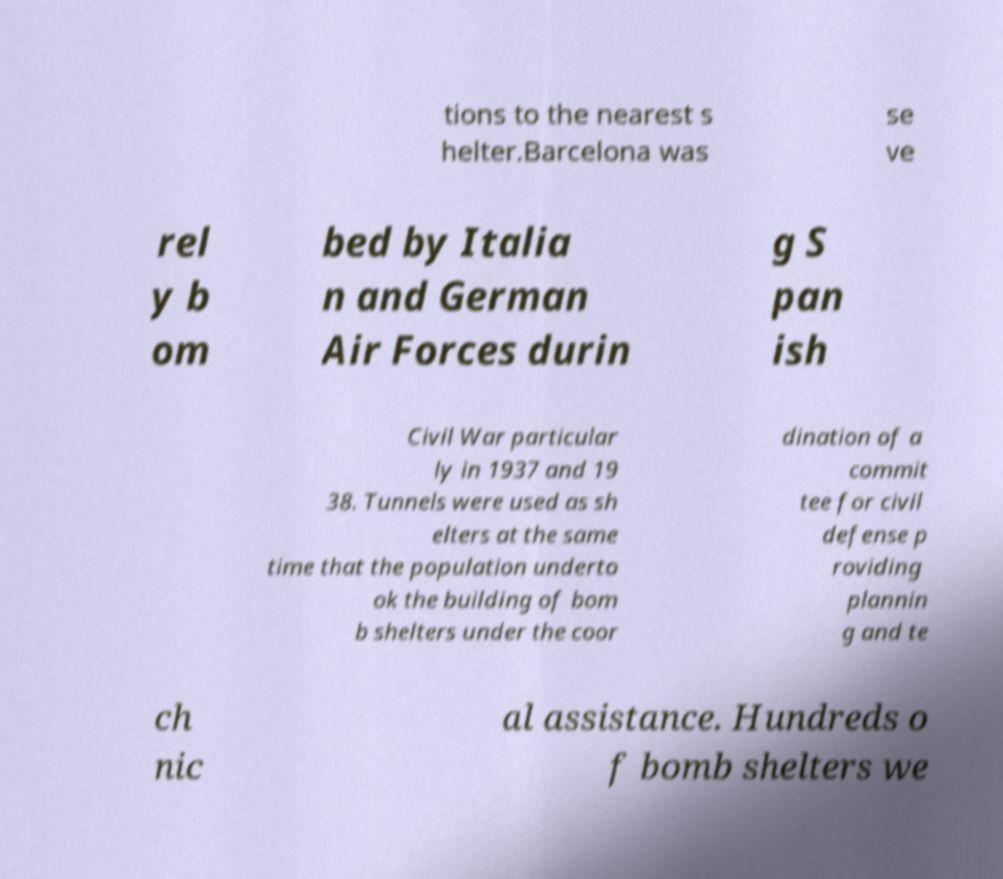What messages or text are displayed in this image? I need them in a readable, typed format. tions to the nearest s helter.Barcelona was se ve rel y b om bed by Italia n and German Air Forces durin g S pan ish Civil War particular ly in 1937 and 19 38. Tunnels were used as sh elters at the same time that the population underto ok the building of bom b shelters under the coor dination of a commit tee for civil defense p roviding plannin g and te ch nic al assistance. Hundreds o f bomb shelters we 